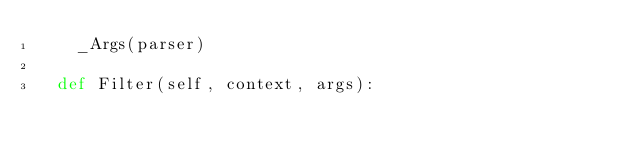<code> <loc_0><loc_0><loc_500><loc_500><_Python_>    _Args(parser)

  def Filter(self, context, args):</code> 